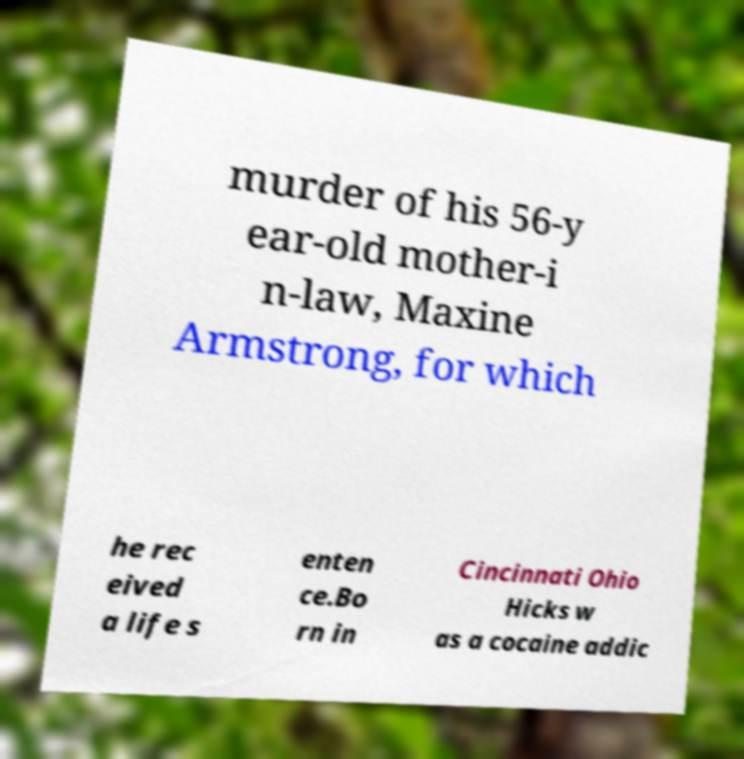I need the written content from this picture converted into text. Can you do that? murder of his 56-y ear-old mother-i n-law, Maxine Armstrong, for which he rec eived a life s enten ce.Bo rn in Cincinnati Ohio Hicks w as a cocaine addic 